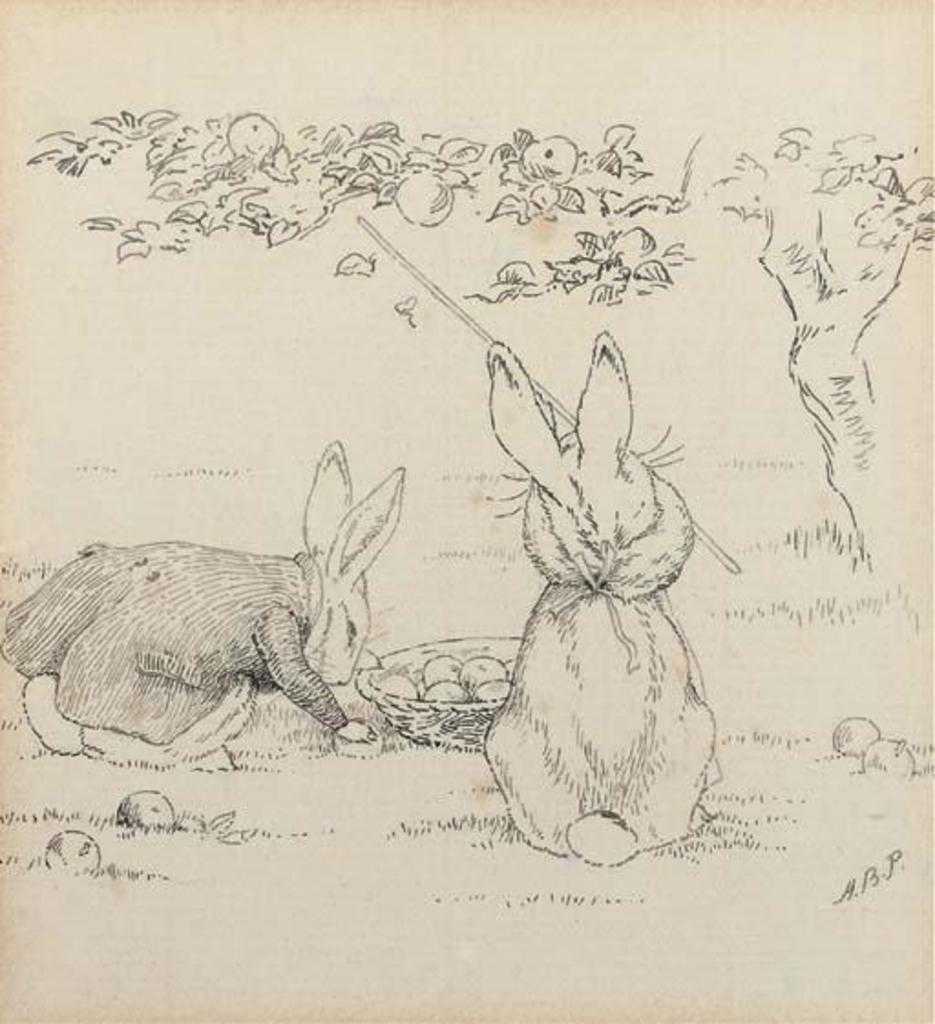Could you give a brief overview of what you see in this image? In the image there is a pencil art of rabbits standing under a fruit tree on the grass land. 